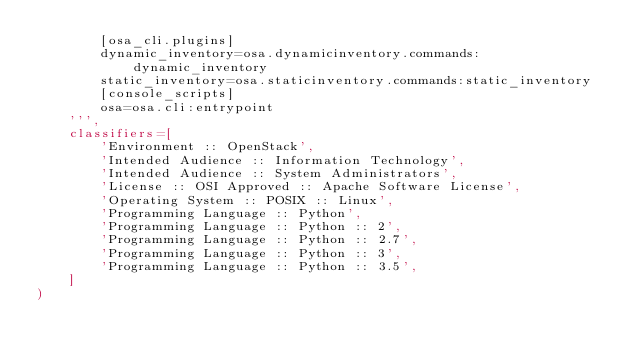Convert code to text. <code><loc_0><loc_0><loc_500><loc_500><_Python_>        [osa_cli.plugins]
        dynamic_inventory=osa.dynamicinventory.commands:dynamic_inventory
        static_inventory=osa.staticinventory.commands:static_inventory
        [console_scripts]
        osa=osa.cli:entrypoint
    ''',
    classifiers=[
        'Environment :: OpenStack',
        'Intended Audience :: Information Technology',
        'Intended Audience :: System Administrators',
        'License :: OSI Approved :: Apache Software License',
        'Operating System :: POSIX :: Linux',
        'Programming Language :: Python',
        'Programming Language :: Python :: 2',
        'Programming Language :: Python :: 2.7',
        'Programming Language :: Python :: 3',
        'Programming Language :: Python :: 3.5',
    ]
)
</code> 